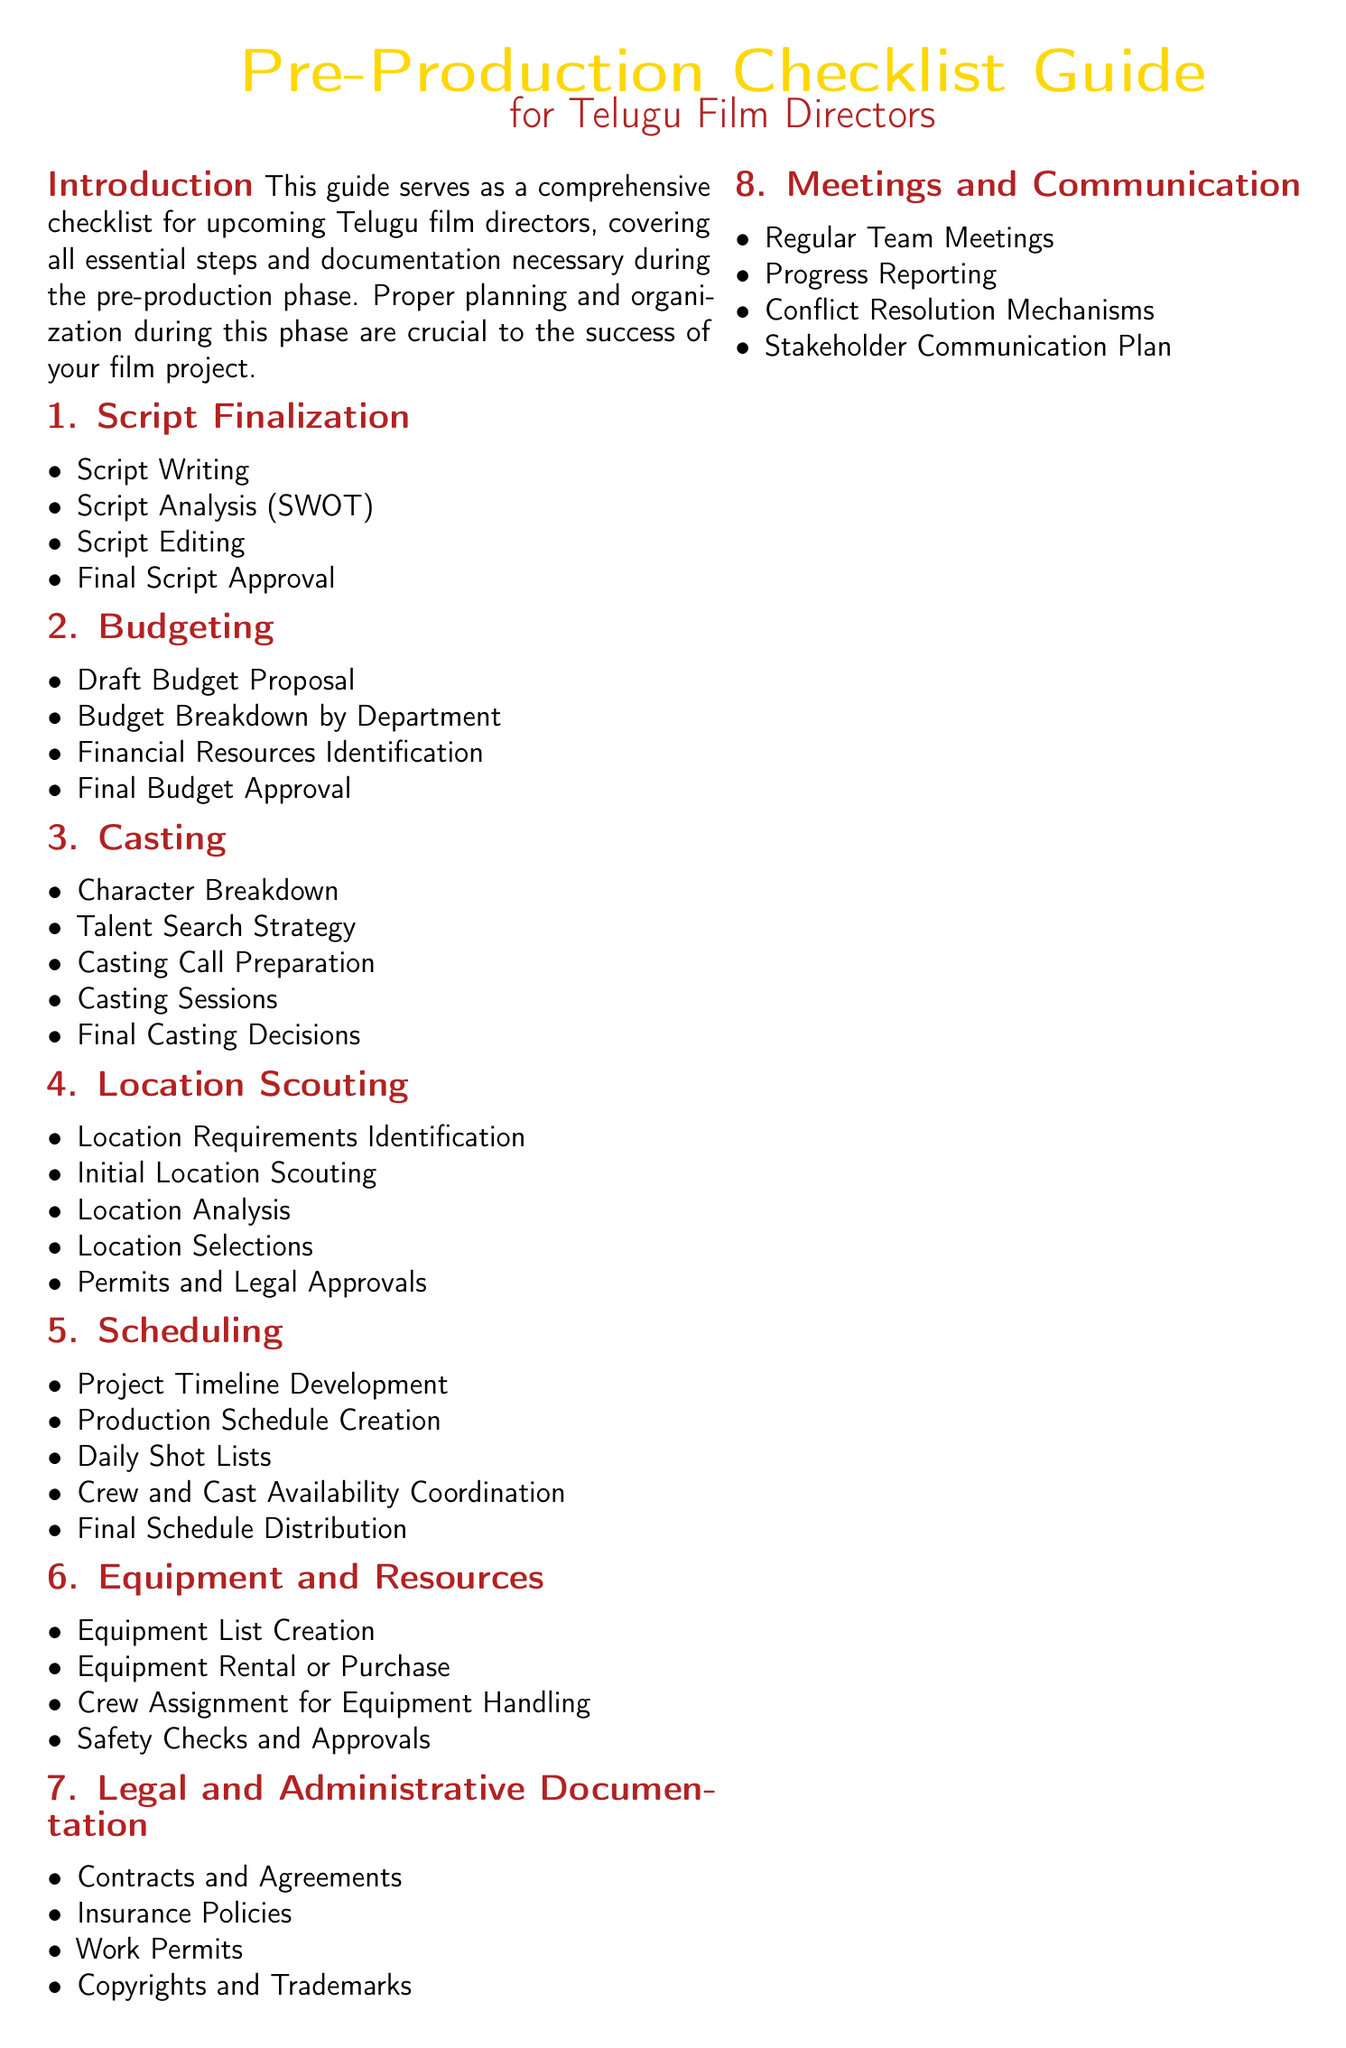what is the title of the guide? The title of the guide is mentioned at the beginning of the document, which is "Pre-Production Checklist Guide."
Answer: Pre-Production Checklist Guide how many sections are in the document? The document outlines a total of eight main sections, which cover essential steps in pre-production.
Answer: Eight what is the first step listed under Budgeting? The first step under Budgeting is identified in the list provided, which is "Draft Budget Proposal."
Answer: Draft Budget Proposal what does the Casting Call Sheet template include? The Casting Call Sheet template consists of several fields, one of which is "Role."
Answer: Role which color is used for section titles? The section titles in the document are styled with the color defined as "telugured."
Answer: telugured what type of documentation is included in Legal and Administrative Documentation? The Legal and Administrative Documentation section includes "Contracts and Agreements."
Answer: Contracts and Agreements what is the last thing written in the document? The last phrase written in the document is a positive note for filmmakers, which is "Happy Filmmaking!"
Answer: Happy Filmmaking! what is the purpose of the Location Scouting Form? The intent of the Location Scouting Form is to collect details about potential locations, including "Location Name."
Answer: Location Name 